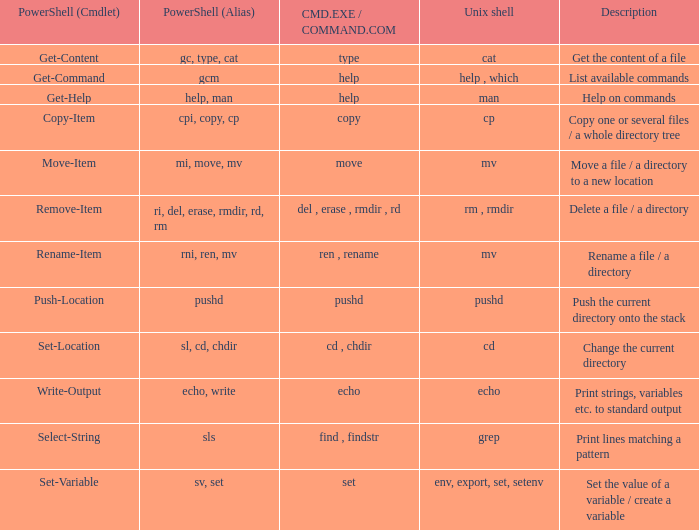If Powershell (alias) is cpi, copy, cp, what are all corresponding descriptions.  Copy one or several files / a whole directory tree. 